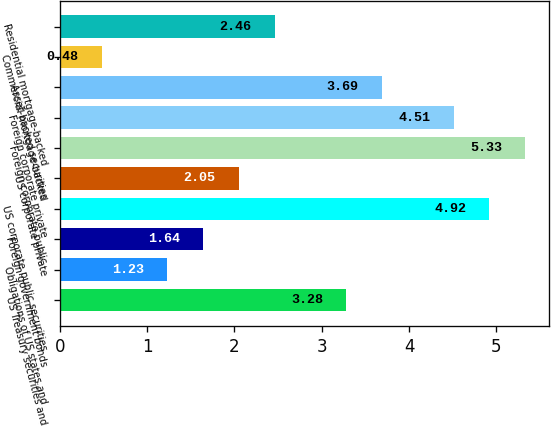Convert chart. <chart><loc_0><loc_0><loc_500><loc_500><bar_chart><fcel>US Treasury securities and<fcel>Obligations of US states and<fcel>Foreign government bonds<fcel>US corporate public securities<fcel>US corporate private<fcel>Foreign corporate public<fcel>Foreign corporate private<fcel>Asset-backed securities<fcel>Commercial mortgage-backed<fcel>Residential mortgage-backed<nl><fcel>3.28<fcel>1.23<fcel>1.64<fcel>4.92<fcel>2.05<fcel>5.33<fcel>4.51<fcel>3.69<fcel>0.48<fcel>2.46<nl></chart> 